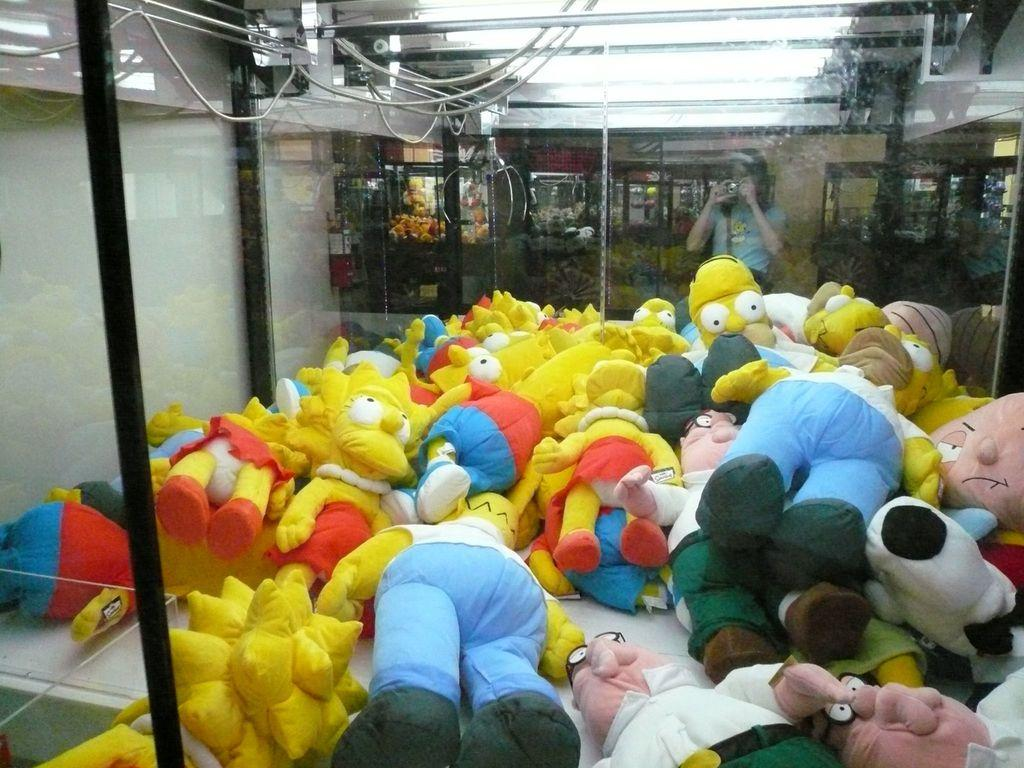What objects can be seen in the image? There are toys in the image. What is visible behind the toys? There is a glass wall behind the toys. Can you describe the person behind the glass wall? A person is standing behind the glass wall. What is the person holding in her hand? The person is holding something in her hand. What type of copper object can be seen in the image? There is no copper object present in the image. What is the mass of the person standing behind the glass wall? The mass of the person cannot be determined from the image alone. 